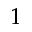<formula> <loc_0><loc_0><loc_500><loc_500>1</formula> 